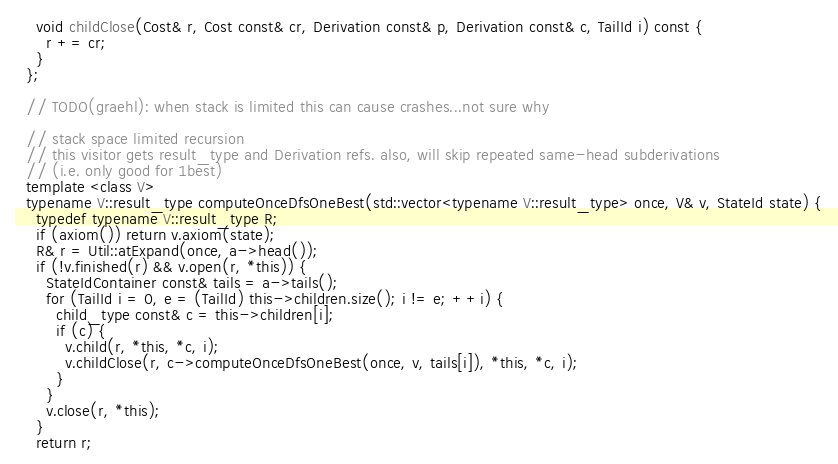Convert code to text. <code><loc_0><loc_0><loc_500><loc_500><_C++_>    void childClose(Cost& r, Cost const& cr, Derivation const& p, Derivation const& c, TailId i) const {
      r += cr;
    }
  };

  // TODO(graehl): when stack is limited this can cause crashes...not sure why

  // stack space limited recursion
  // this visitor gets result_type and Derivation refs. also, will skip repeated same-head subderivations
  // (i.e. only good for 1best)
  template <class V>
  typename V::result_type computeOnceDfsOneBest(std::vector<typename V::result_type> once, V& v, StateId state) {
    typedef typename V::result_type R;
    if (axiom()) return v.axiom(state);
    R& r = Util::atExpand(once, a->head());
    if (!v.finished(r) && v.open(r, *this)) {
      StateIdContainer const& tails = a->tails();
      for (TailId i = 0, e = (TailId) this->children.size(); i != e; ++i) {
        child_type const& c = this->children[i];
        if (c) {
          v.child(r, *this, *c, i);
          v.childClose(r, c->computeOnceDfsOneBest(once, v, tails[i]), *this, *c, i);
        }
      }
      v.close(r, *this);
    }
    return r;</code> 